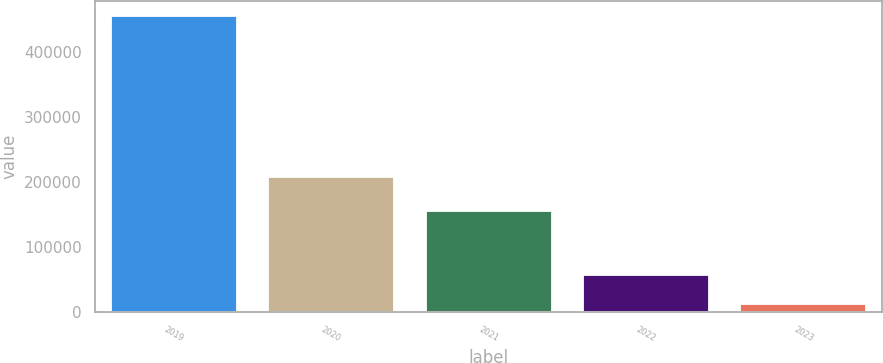Convert chart to OTSL. <chart><loc_0><loc_0><loc_500><loc_500><bar_chart><fcel>2019<fcel>2020<fcel>2021<fcel>2022<fcel>2023<nl><fcel>455000<fcel>207000<fcel>155000<fcel>56300<fcel>12000<nl></chart> 